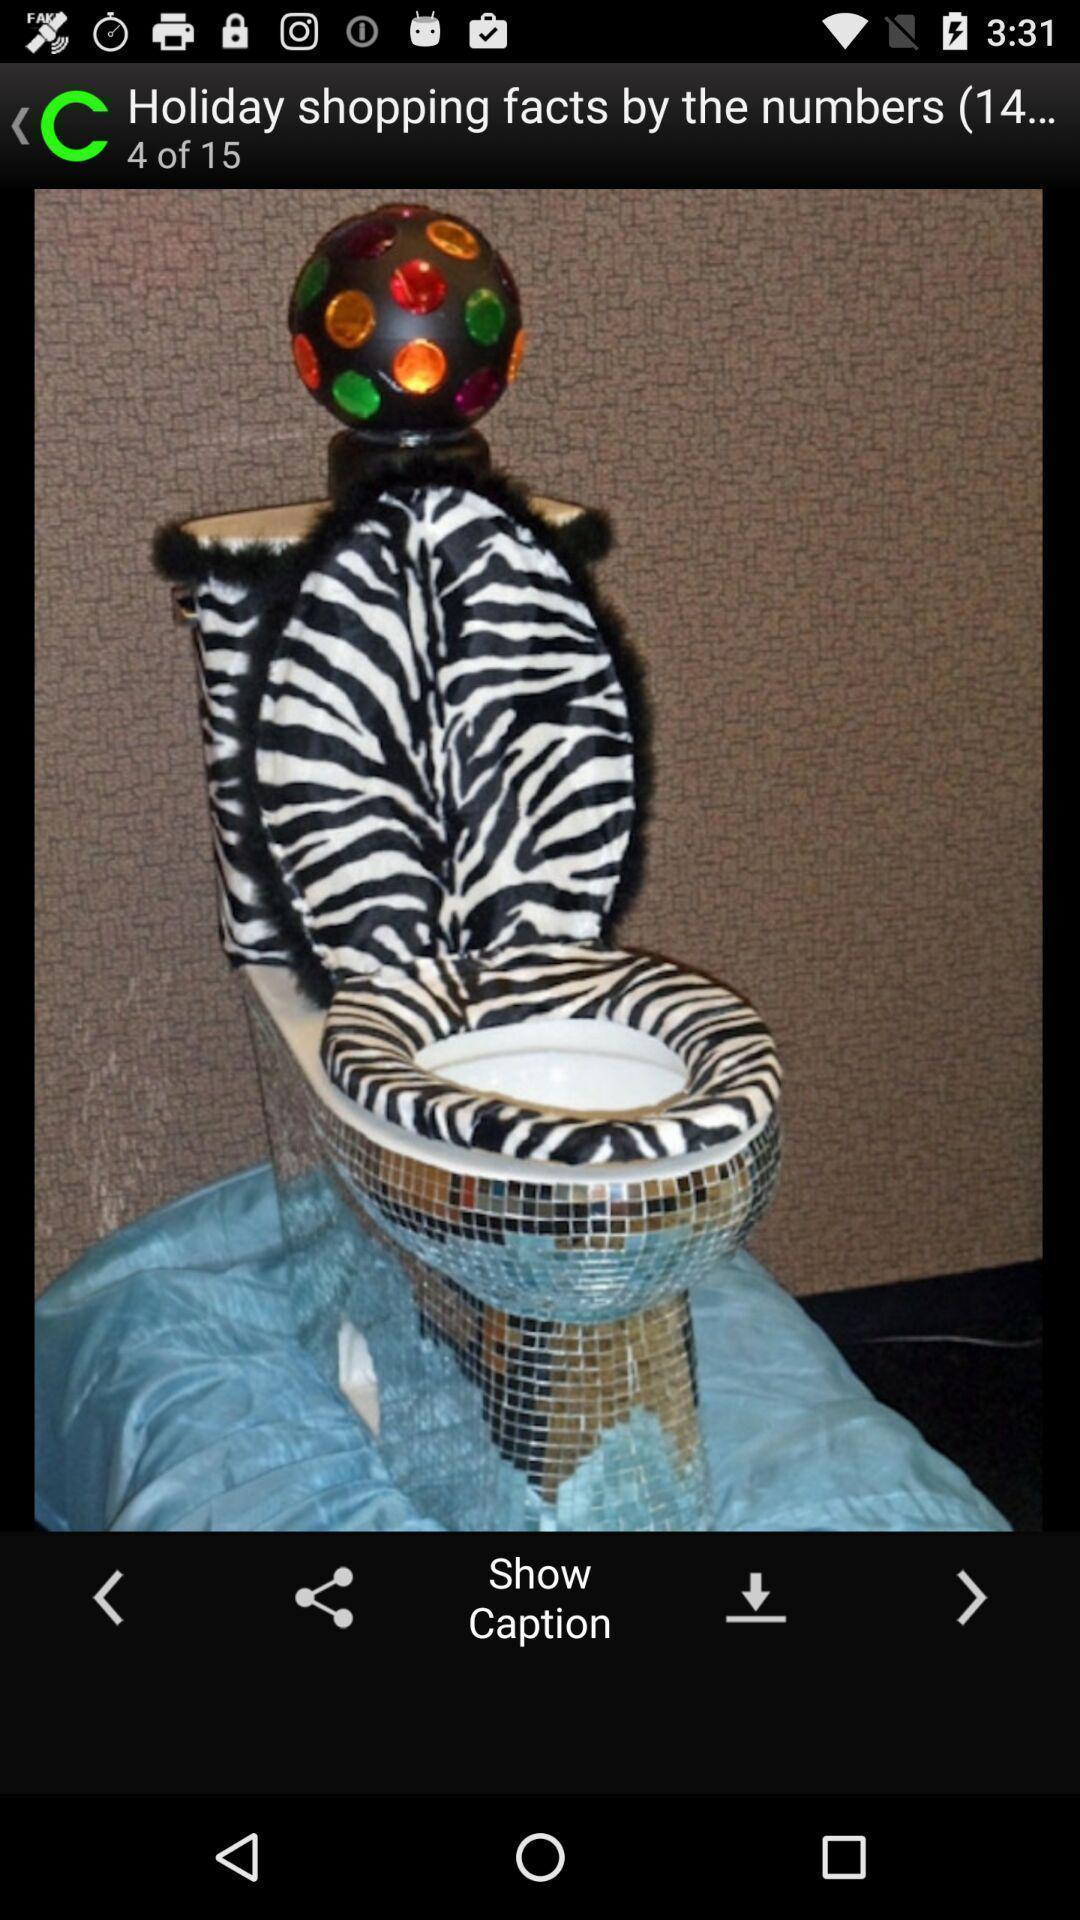Tell me about the visual elements in this screen capture. Screen displaying the image of a western toilet. 